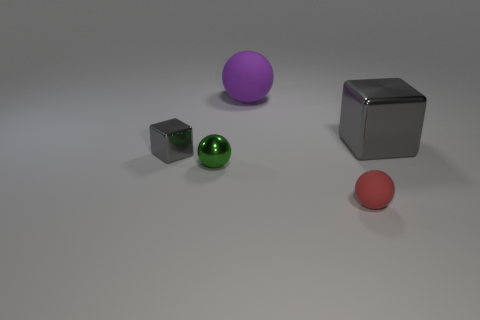Subtract all matte balls. How many balls are left? 1 Subtract 2 spheres. How many spheres are left? 1 Subtract all gray balls. Subtract all gray cylinders. How many balls are left? 3 Subtract all gray cylinders. How many red balls are left? 1 Subtract all gray rubber objects. Subtract all big rubber things. How many objects are left? 4 Add 2 small metallic objects. How many small metallic objects are left? 4 Add 2 green objects. How many green objects exist? 3 Add 1 small red spheres. How many objects exist? 6 Subtract all green balls. How many balls are left? 2 Subtract 0 brown cubes. How many objects are left? 5 